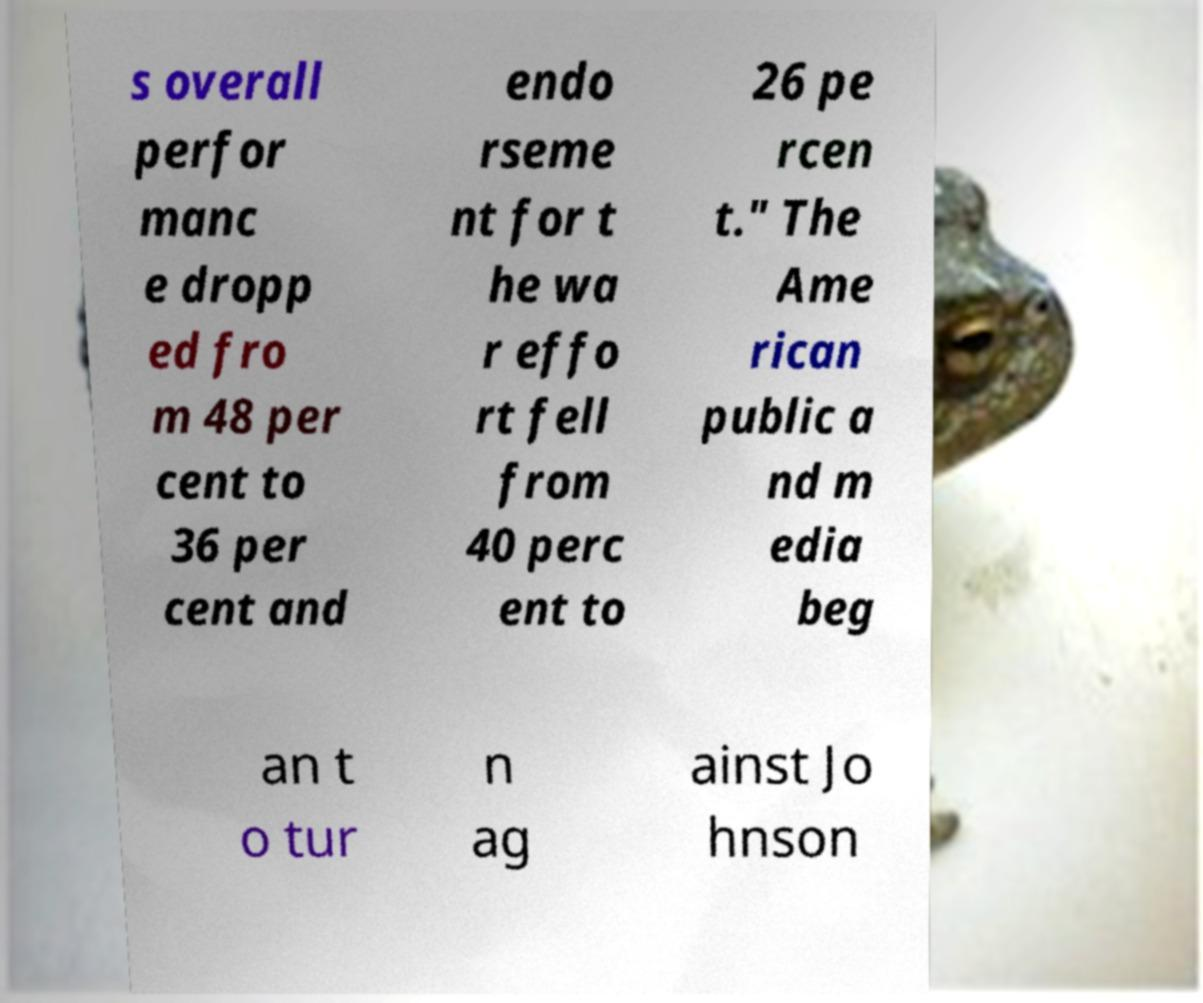Can you accurately transcribe the text from the provided image for me? s overall perfor manc e dropp ed fro m 48 per cent to 36 per cent and endo rseme nt for t he wa r effo rt fell from 40 perc ent to 26 pe rcen t." The Ame rican public a nd m edia beg an t o tur n ag ainst Jo hnson 